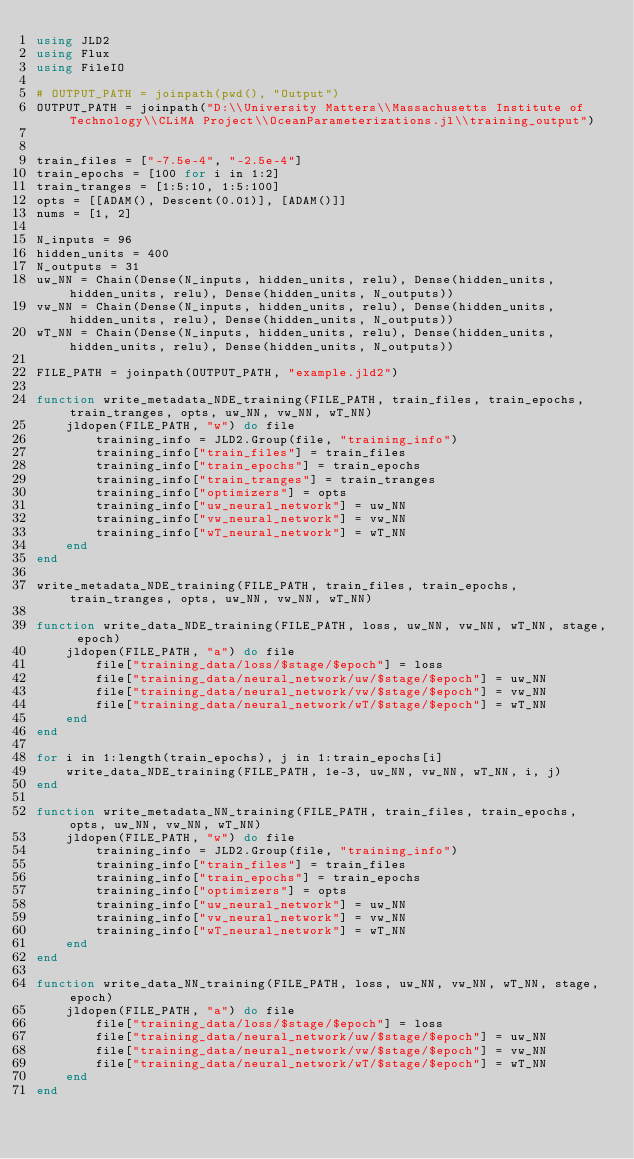Convert code to text. <code><loc_0><loc_0><loc_500><loc_500><_Julia_>using JLD2
using Flux
using FileIO

# OUTPUT_PATH = joinpath(pwd(), "Output")
OUTPUT_PATH = joinpath("D:\\University Matters\\Massachusetts Institute of Technology\\CLiMA Project\\OceanParameterizations.jl\\training_output")


train_files = ["-7.5e-4", "-2.5e-4"]
train_epochs = [100 for i in 1:2]
train_tranges = [1:5:10, 1:5:100]
opts = [[ADAM(), Descent(0.01)], [ADAM()]]
nums = [1, 2]

N_inputs = 96
hidden_units = 400
N_outputs = 31
uw_NN = Chain(Dense(N_inputs, hidden_units, relu), Dense(hidden_units, hidden_units, relu), Dense(hidden_units, N_outputs))
vw_NN = Chain(Dense(N_inputs, hidden_units, relu), Dense(hidden_units, hidden_units, relu), Dense(hidden_units, N_outputs))
wT_NN = Chain(Dense(N_inputs, hidden_units, relu), Dense(hidden_units, hidden_units, relu), Dense(hidden_units, N_outputs))

FILE_PATH = joinpath(OUTPUT_PATH, "example.jld2")

function write_metadata_NDE_training(FILE_PATH, train_files, train_epochs, train_tranges, opts, uw_NN, vw_NN, wT_NN)
    jldopen(FILE_PATH, "w") do file
        training_info = JLD2.Group(file, "training_info")
        training_info["train_files"] = train_files
        training_info["train_epochs"] = train_epochs
        training_info["train_tranges"] = train_tranges
        training_info["optimizers"] = opts
        training_info["uw_neural_network"] = uw_NN
        training_info["vw_neural_network"] = vw_NN
        training_info["wT_neural_network"] = wT_NN
    end
end

write_metadata_NDE_training(FILE_PATH, train_files, train_epochs, train_tranges, opts, uw_NN, vw_NN, wT_NN)

function write_data_NDE_training(FILE_PATH, loss, uw_NN, vw_NN, wT_NN, stage, epoch)
    jldopen(FILE_PATH, "a") do file
        file["training_data/loss/$stage/$epoch"] = loss
        file["training_data/neural_network/uw/$stage/$epoch"] = uw_NN
        file["training_data/neural_network/vw/$stage/$epoch"] = vw_NN
        file["training_data/neural_network/wT/$stage/$epoch"] = wT_NN
    end
end

for i in 1:length(train_epochs), j in 1:train_epochs[i]
    write_data_NDE_training(FILE_PATH, 1e-3, uw_NN, vw_NN, wT_NN, i, j)
end

function write_metadata_NN_training(FILE_PATH, train_files, train_epochs, opts, uw_NN, vw_NN, wT_NN)
    jldopen(FILE_PATH, "w") do file
        training_info = JLD2.Group(file, "training_info")
        training_info["train_files"] = train_files
        training_info["train_epochs"] = train_epochs
        training_info["optimizers"] = opts
        training_info["uw_neural_network"] = uw_NN
        training_info["vw_neural_network"] = vw_NN
        training_info["wT_neural_network"] = wT_NN
    end
end

function write_data_NN_training(FILE_PATH, loss, uw_NN, vw_NN, wT_NN, stage, epoch)
    jldopen(FILE_PATH, "a") do file
        file["training_data/loss/$stage/$epoch"] = loss
        file["training_data/neural_network/uw/$stage/$epoch"] = uw_NN
        file["training_data/neural_network/vw/$stage/$epoch"] = vw_NN
        file["training_data/neural_network/wT/$stage/$epoch"] = wT_NN
    end
end</code> 